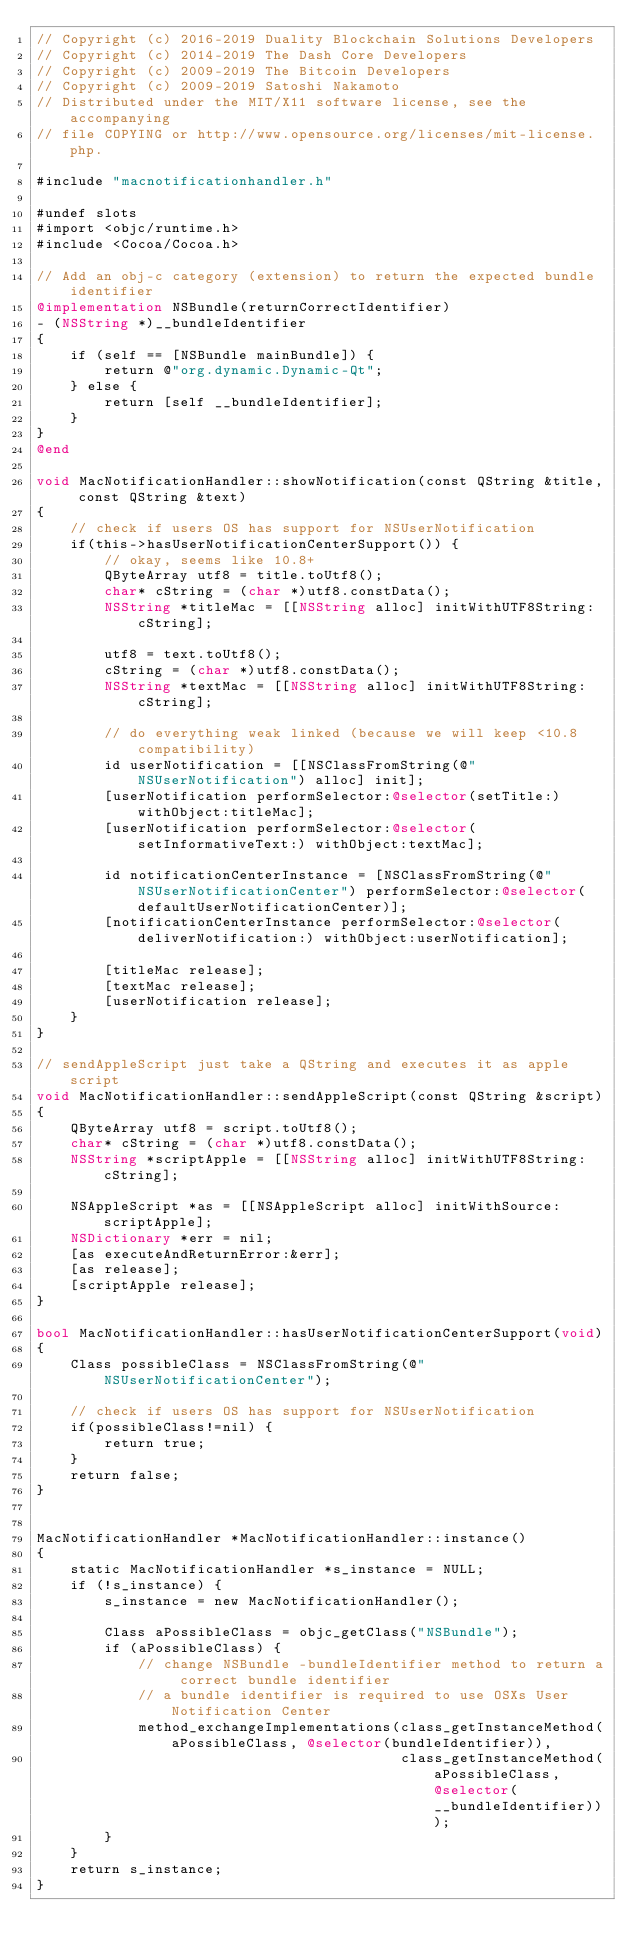<code> <loc_0><loc_0><loc_500><loc_500><_ObjectiveC_>// Copyright (c) 2016-2019 Duality Blockchain Solutions Developers
// Copyright (c) 2014-2019 The Dash Core Developers
// Copyright (c) 2009-2019 The Bitcoin Developers
// Copyright (c) 2009-2019 Satoshi Nakamoto
// Distributed under the MIT/X11 software license, see the accompanying
// file COPYING or http://www.opensource.org/licenses/mit-license.php.

#include "macnotificationhandler.h"

#undef slots
#import <objc/runtime.h>
#include <Cocoa/Cocoa.h>

// Add an obj-c category (extension) to return the expected bundle identifier
@implementation NSBundle(returnCorrectIdentifier)
- (NSString *)__bundleIdentifier
{
    if (self == [NSBundle mainBundle]) {
        return @"org.dynamic.Dynamic-Qt";
    } else {
        return [self __bundleIdentifier];
    }
}
@end

void MacNotificationHandler::showNotification(const QString &title, const QString &text)
{
    // check if users OS has support for NSUserNotification
    if(this->hasUserNotificationCenterSupport()) {
        // okay, seems like 10.8+
        QByteArray utf8 = title.toUtf8();
        char* cString = (char *)utf8.constData();
        NSString *titleMac = [[NSString alloc] initWithUTF8String:cString];

        utf8 = text.toUtf8();
        cString = (char *)utf8.constData();
        NSString *textMac = [[NSString alloc] initWithUTF8String:cString];

        // do everything weak linked (because we will keep <10.8 compatibility)
        id userNotification = [[NSClassFromString(@"NSUserNotification") alloc] init];
        [userNotification performSelector:@selector(setTitle:) withObject:titleMac];
        [userNotification performSelector:@selector(setInformativeText:) withObject:textMac];

        id notificationCenterInstance = [NSClassFromString(@"NSUserNotificationCenter") performSelector:@selector(defaultUserNotificationCenter)];
        [notificationCenterInstance performSelector:@selector(deliverNotification:) withObject:userNotification];

        [titleMac release];
        [textMac release];
        [userNotification release];
    }
}

// sendAppleScript just take a QString and executes it as apple script
void MacNotificationHandler::sendAppleScript(const QString &script)
{
    QByteArray utf8 = script.toUtf8();
    char* cString = (char *)utf8.constData();
    NSString *scriptApple = [[NSString alloc] initWithUTF8String:cString];

    NSAppleScript *as = [[NSAppleScript alloc] initWithSource:scriptApple];
    NSDictionary *err = nil;
    [as executeAndReturnError:&err];
    [as release];
    [scriptApple release];
}

bool MacNotificationHandler::hasUserNotificationCenterSupport(void)
{
    Class possibleClass = NSClassFromString(@"NSUserNotificationCenter");

    // check if users OS has support for NSUserNotification
    if(possibleClass!=nil) {
        return true;
    }
    return false;
}


MacNotificationHandler *MacNotificationHandler::instance()
{
    static MacNotificationHandler *s_instance = NULL;
    if (!s_instance) {
        s_instance = new MacNotificationHandler();
        
        Class aPossibleClass = objc_getClass("NSBundle");
        if (aPossibleClass) {
            // change NSBundle -bundleIdentifier method to return a correct bundle identifier
            // a bundle identifier is required to use OSXs User Notification Center
            method_exchangeImplementations(class_getInstanceMethod(aPossibleClass, @selector(bundleIdentifier)),
                                           class_getInstanceMethod(aPossibleClass, @selector(__bundleIdentifier)));
        }
    }
    return s_instance;
}
</code> 